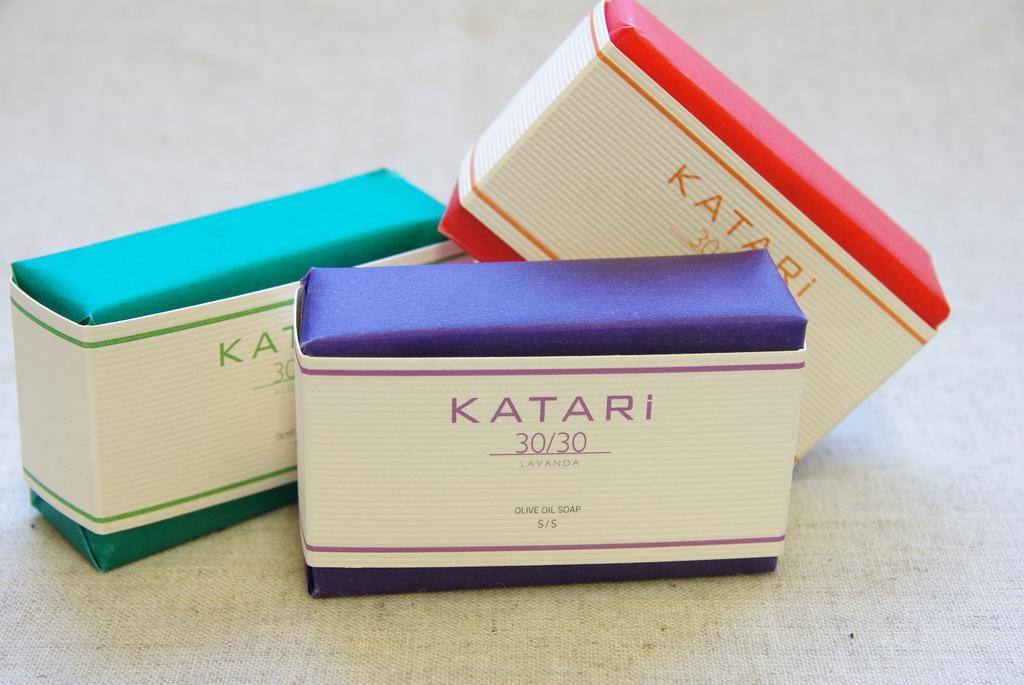<image>
Describe the image concisely. A stack of three colorful boxes of Katari 30/30. 